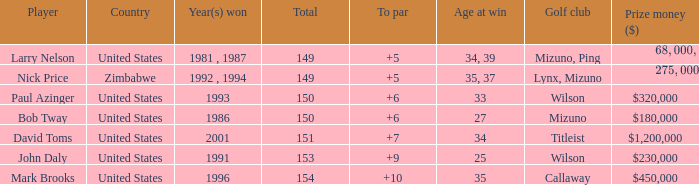How many to pars were won in 1993? 1.0. 